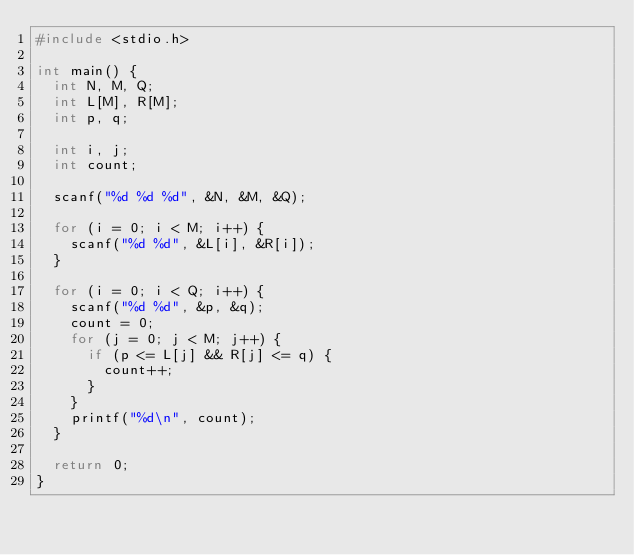Convert code to text. <code><loc_0><loc_0><loc_500><loc_500><_C_>#include <stdio.h>

int main() {
  int N, M, Q;
  int L[M], R[M];
  int p, q;

  int i, j;
  int count;

  scanf("%d %d %d", &N, &M, &Q);

  for (i = 0; i < M; i++) {
    scanf("%d %d", &L[i], &R[i]);
  }

  for (i = 0; i < Q; i++) {
    scanf("%d %d", &p, &q);
    count = 0;
    for (j = 0; j < M; j++) {
      if (p <= L[j] && R[j] <= q) {
        count++;
      }
    }
    printf("%d\n", count);
  }

  return 0;
}
</code> 